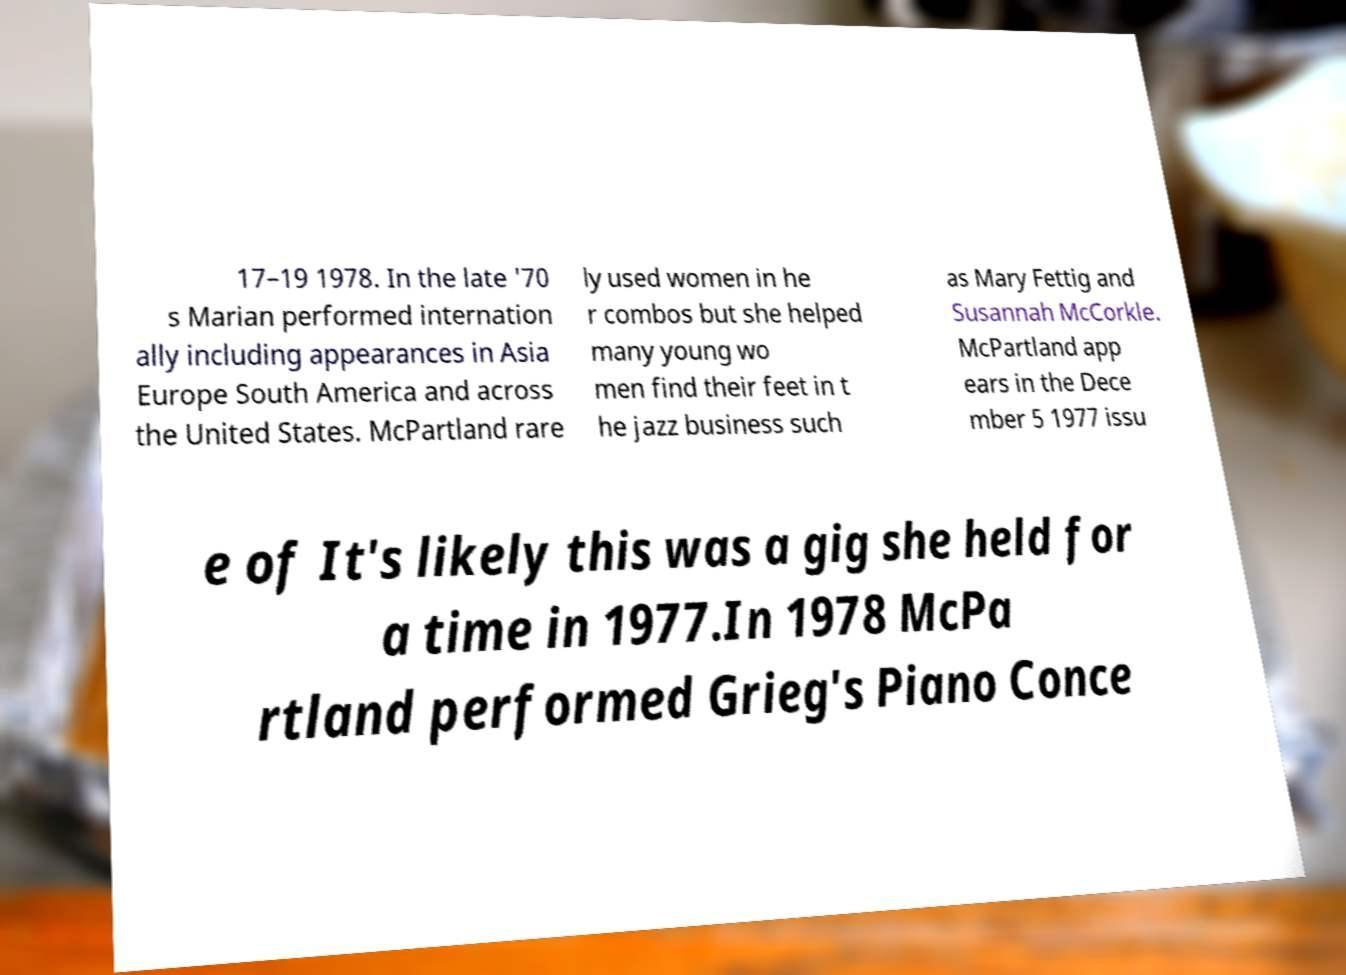For documentation purposes, I need the text within this image transcribed. Could you provide that? 17–19 1978. In the late '70 s Marian performed internation ally including appearances in Asia Europe South America and across the United States. McPartland rare ly used women in he r combos but she helped many young wo men find their feet in t he jazz business such as Mary Fettig and Susannah McCorkle. McPartland app ears in the Dece mber 5 1977 issu e of It's likely this was a gig she held for a time in 1977.In 1978 McPa rtland performed Grieg's Piano Conce 